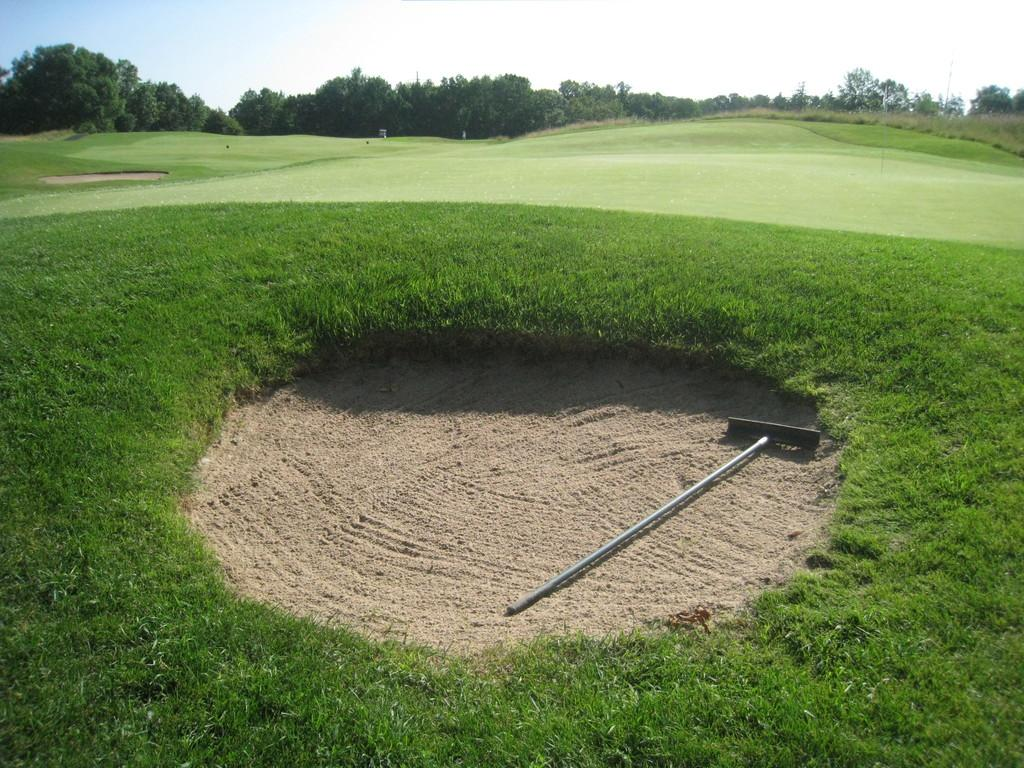What is sticking out of the sand in the image? There is a metal rod in the sand. What type of vegetation can be seen in the image? There are trees and grass in the image. What other structures are present in the image? There are poles in the image. What part of the natural environment is visible in the image? The sky is visible in the image. What type of scissors can be seen cutting the record in the image? There is no record or scissors present in the image. 